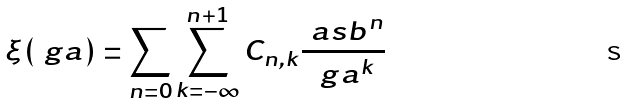<formula> <loc_0><loc_0><loc_500><loc_500>\xi ( \ g a ) = \sum _ { n = 0 } \sum _ { k = - \infty } ^ { n + 1 } C _ { n , k } \frac { \ a s b ^ { n } } { \ g a ^ { k } } \,</formula> 